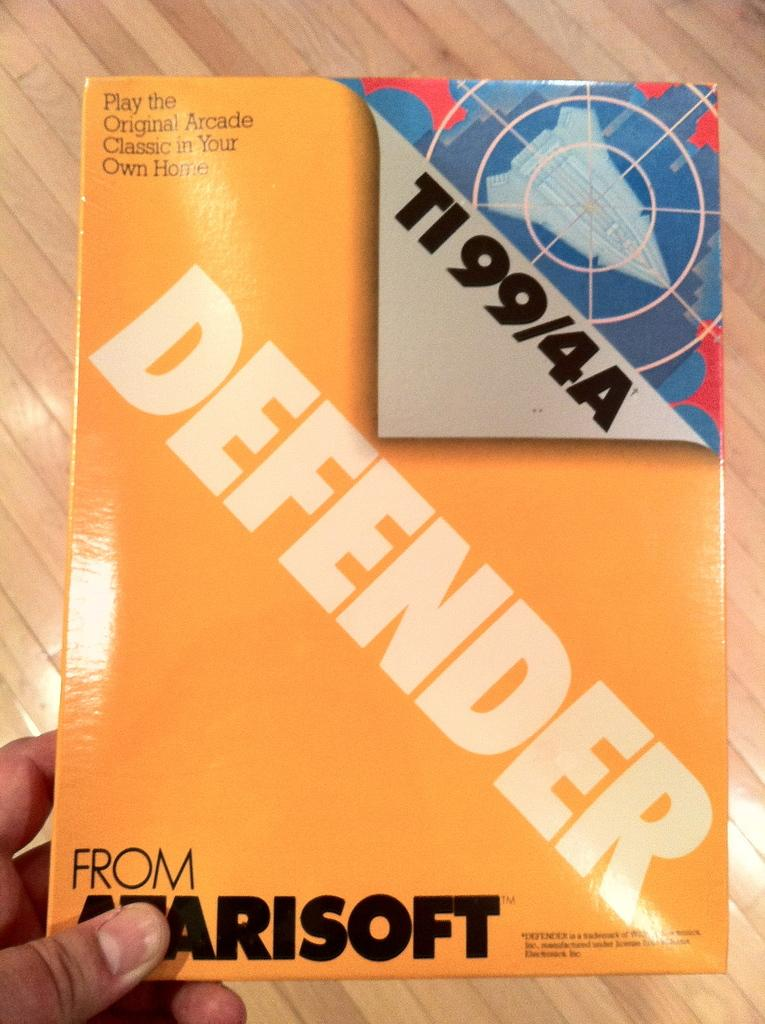<image>
Summarize the visual content of the image. Someone holding a package of a Defender computer game 